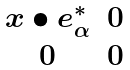Convert formula to latex. <formula><loc_0><loc_0><loc_500><loc_500>\begin{matrix} x \bullet e _ { \alpha } ^ { * } & 0 \\ 0 & 0 \end{matrix}</formula> 